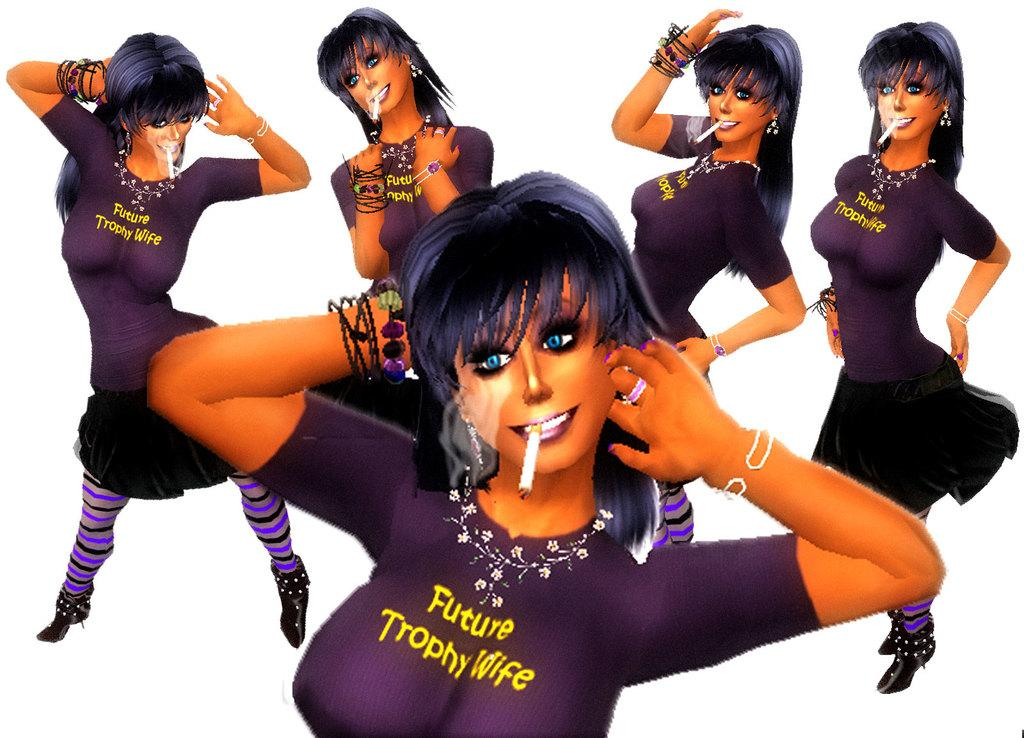What type of image is being described? The image is animated. How is the person in the image depicted? The same person appears in different places in the image. What is the person holding in their mouth in each appearance? The person has a cigarette in their mouth in each appearance. What color is the background of the image? The background of the image is white. What type of weather condition is present in the image? There is no mention of weather conditions in the image; it only describes an animated scene with a person appearing in different places, holding a cigarette in their mouth, and a white background. 